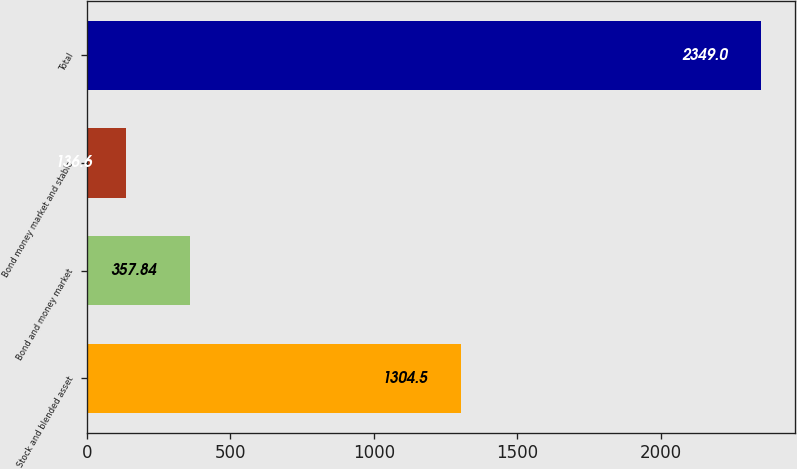<chart> <loc_0><loc_0><loc_500><loc_500><bar_chart><fcel>Stock and blended asset<fcel>Bond and money market<fcel>Bond money market and stable<fcel>Total<nl><fcel>1304.5<fcel>357.84<fcel>136.6<fcel>2349<nl></chart> 